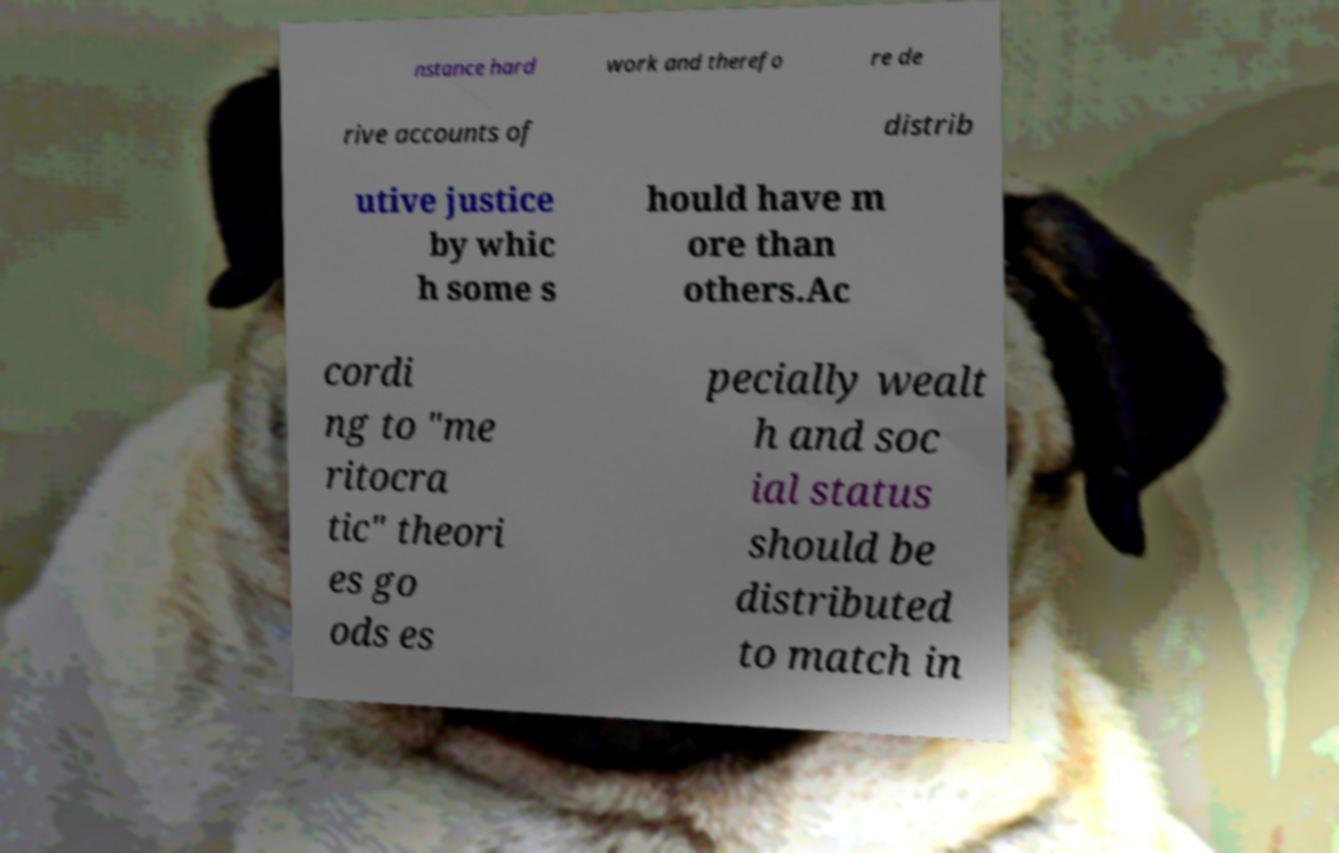Please identify and transcribe the text found in this image. nstance hard work and therefo re de rive accounts of distrib utive justice by whic h some s hould have m ore than others.Ac cordi ng to "me ritocra tic" theori es go ods es pecially wealt h and soc ial status should be distributed to match in 